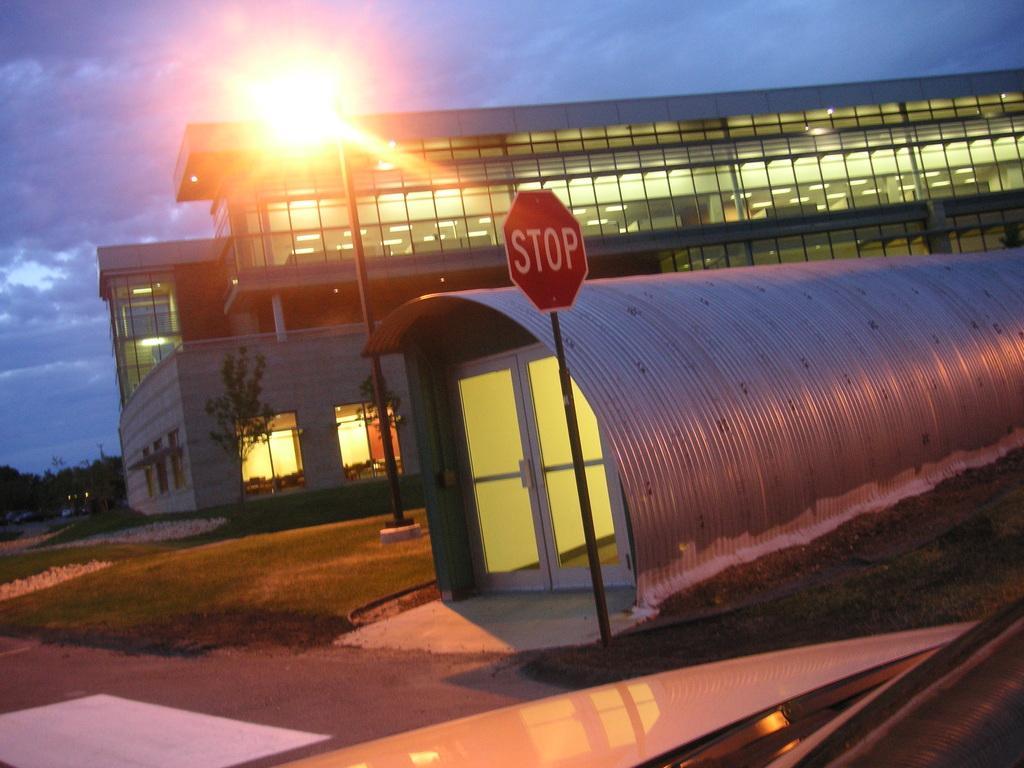<image>
Describe the image concisely. Large building behind a red STOP sign on the street. 